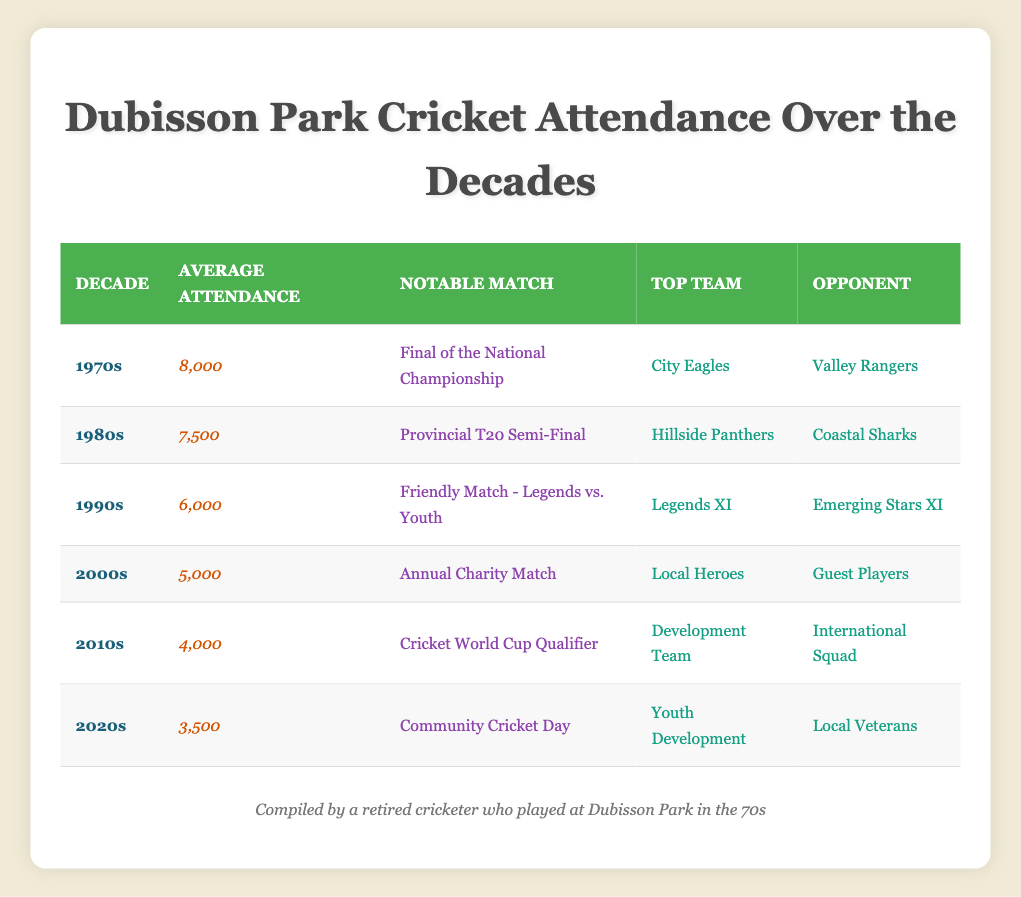What was the average attendance in the 1970s? The table shows that the average attendance in the 1970s is listed under the column "Average Attendance" for that decade, which is 8000.
Answer: 8000 Which decade had the lowest average attendance? By reviewing the "Average Attendance" across all decades, the 2020s has the lowest attendance at 3500.
Answer: 2020s Did the attendance increase from the 1970s to the 1980s? Looking at the averages, the attendance in the 1970s was 8000 and in the 1980s it was 7500. Since 7500 is less than 8000, attendance did not increase.
Answer: No What is the difference in average attendance between the 1970s and the 2000s? The average attendance in the 1970s is 8000 and in the 2000s it is 5000. The difference is calculated as 8000 - 5000 = 3000.
Answer: 3000 Which notable match corresponded with the highest attendance decade? The highest attendance was in the 1970s (8000) and the notable match for that decade is the "Final of the National Championship".
Answer: Final of the National Championship What were the averages of the 1990s and 2000s combined? The average attendance in the 1990s is 6000 and in the 2000s is 5000. To find the combined average, we add the two values (6000 + 5000 = 11000) and divide by 2, giving us 5500.
Answer: 5500 Which team played against the Local Heroes in the 2000s? The data indicates that in the 2000s, the Local Heroes played against the Guest Players, as mentioned under the "Top Team" and "Opponent" columns.
Answer: Guest Players Is there a decade where the average attendance was 4000 or higher? By checking the average attendances, we see that the 1970s, 1980s, 1990s, and 2000s all have figures above 4000. Therefore, there are decades with average attendance of 4000 or higher.
Answer: Yes What is the average attendance for the 2010s compared to the 2020s? In the 2010s, the average is 4000 and in the 2020s it's 3500. To compare, we note that 4000 is greater than 3500, showing a decline in the most recent decade.
Answer: 2010s had higher attendance 